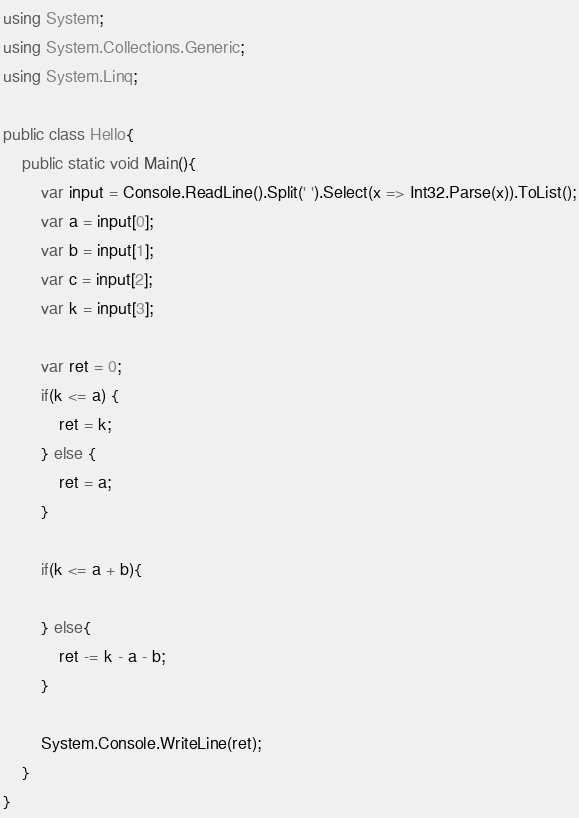<code> <loc_0><loc_0><loc_500><loc_500><_C#_>using System;
using System.Collections.Generic;
using System.Linq;

public class Hello{
    public static void Main(){
        var input = Console.ReadLine().Split(' ').Select(x => Int32.Parse(x)).ToList();
        var a = input[0];
        var b = input[1];
        var c = input[2];
        var k = input[3];
        
        var ret = 0;
        if(k <= a) {
            ret = k;
        } else {
            ret = a;
        }

        if(k <= a + b){
            
        } else{
            ret -= k - a - b;
        }

        System.Console.WriteLine(ret);
    }
}
</code> 